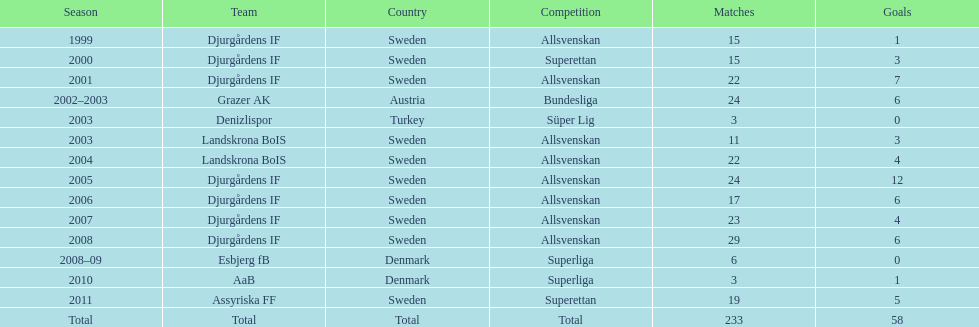What country does team djurgårdens if not belong to? Sweden. 